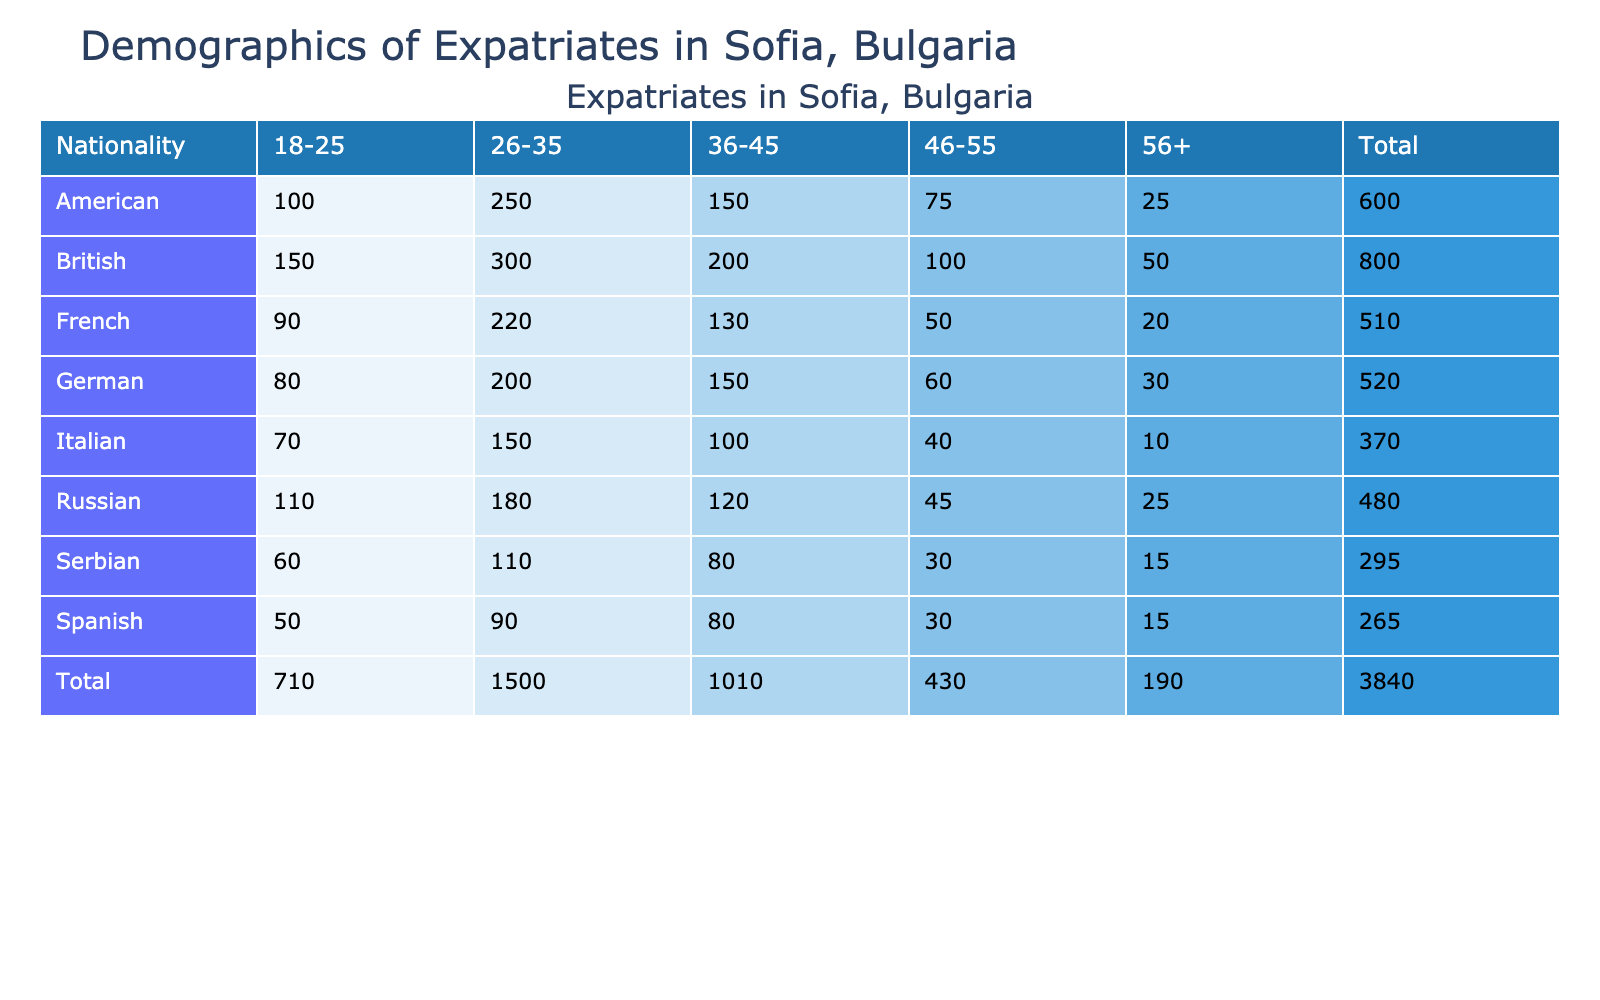What is the total number of British expatriates in Sofia? To find the total, I sum the numbers in the 'Number of Expatriates' column for British across all age groups: 150 + 300 + 200 + 100 + 50 = 800.
Answer: 800 Which nationality has the highest number of expatriates in the age group 26-35? I look at the '26-35' age group for all nationalities: British has 300, American has 250, German has 200, French has 220, Italian has 150, Spanish has 90, Russian has 180, and Serbian has 110. The highest is British with 300.
Answer: British How many expatriates aged 56 and older are from France? I refer to the '56+' age group for France, which shows 20 expatriates.
Answer: 20 What is the average age group size for American expatriates? I calculate the average by summing the number of American expatriates across all age groups: 100 + 250 + 150 + 75 + 25 = 600. There are 5 age groups, so the average is 600 / 5 = 120.
Answer: 120 Is it true that there are more Russian expatriates in Sofia than Italian expatriates? I compare the total number of Russian expatriates (when summed up: 110 + 180 + 120 + 45 + 25 = 480) to the total number of Italian expatriates (summing: 70 + 150 + 100 + 40 + 10 = 370). Since 480 is greater than 370, the statement is true.
Answer: Yes What is the total count of expatriates aged 36 to 45 from all nationalities combined? I will sum the values in the '36-45' age group: British (200) + American (150) + German (150) + French (130) + Italian (100) + Spanish (80) + Russian (120) + Serbian (80) = 1,010.
Answer: 1,010 Which age group has the least number of expatriates overall? I examine the totals for each age group: 18-25 (150 + 100 + 80 + 90 + 70 + 50 + 110 + 60 = 800), 26-35 (300 + 250 + 200 + 220 + 150 + 90 + 180 + 110 = 1,610), 36-45 (200 + 150 + 150 + 130 + 100 + 80 + 120 + 80 = 1,110), 46-55 (100 + 75 + 60 + 50 + 40 + 30 + 45 + 30 = 430), and 56+ (50 + 25 + 30 + 20 + 10 + 15 + 25 + 15 = 215). The least is 56+ with a total of 215.
Answer: 56+ What is the difference in the number of expatriates between the age groups 18-25 and 46-55? First, I find the totals: 18-25 has 800 expatriates and 46-55 has 430. The difference is 800 - 430 = 370.
Answer: 370 What nationality has the lowest representation in the 56+ age group? I compare the '56+' values: British (50), American (25), German (30), French (20), Italian (10), Spanish (15), Russian (25), Serbian (15). The lowest value is Italian with 10 expatriates.
Answer: Italian 